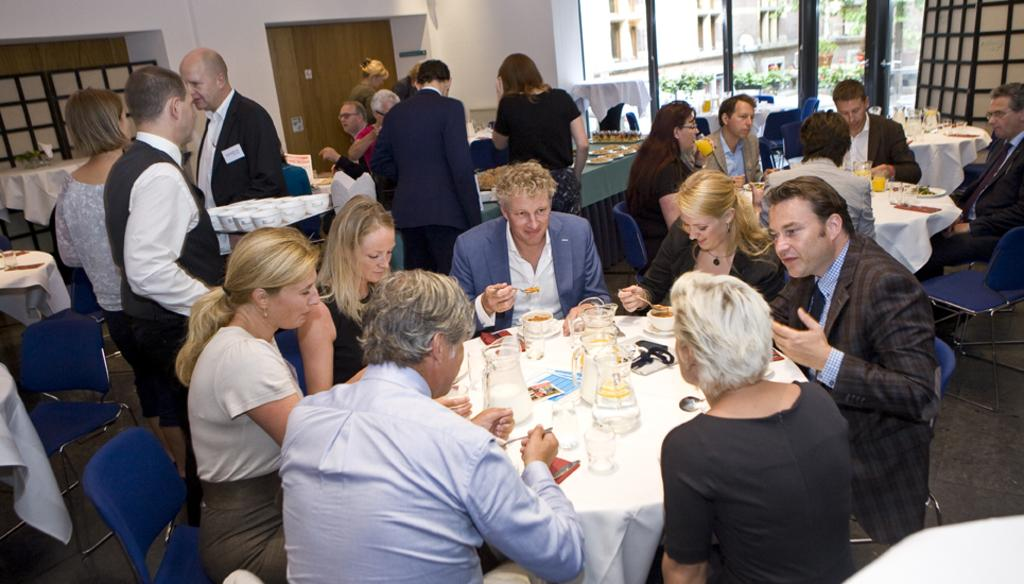How many people are in the image? There is a group of people in the image. What are the people doing in the image? The people are sitting on chairs and having food. What is on the table in front of the seated people? There is a table in front of the seated people, and there are jars of water on the table. Are there any people standing in the image? Yes, some people are standing in the image. What can be seen outside the building in the image? There is a building visible outside, but the specific details of what can be seen outside are not mentioned in the facts. Are there any pets visible in the image? There is no mention of pets in the image, so we cannot determine if any are present. 